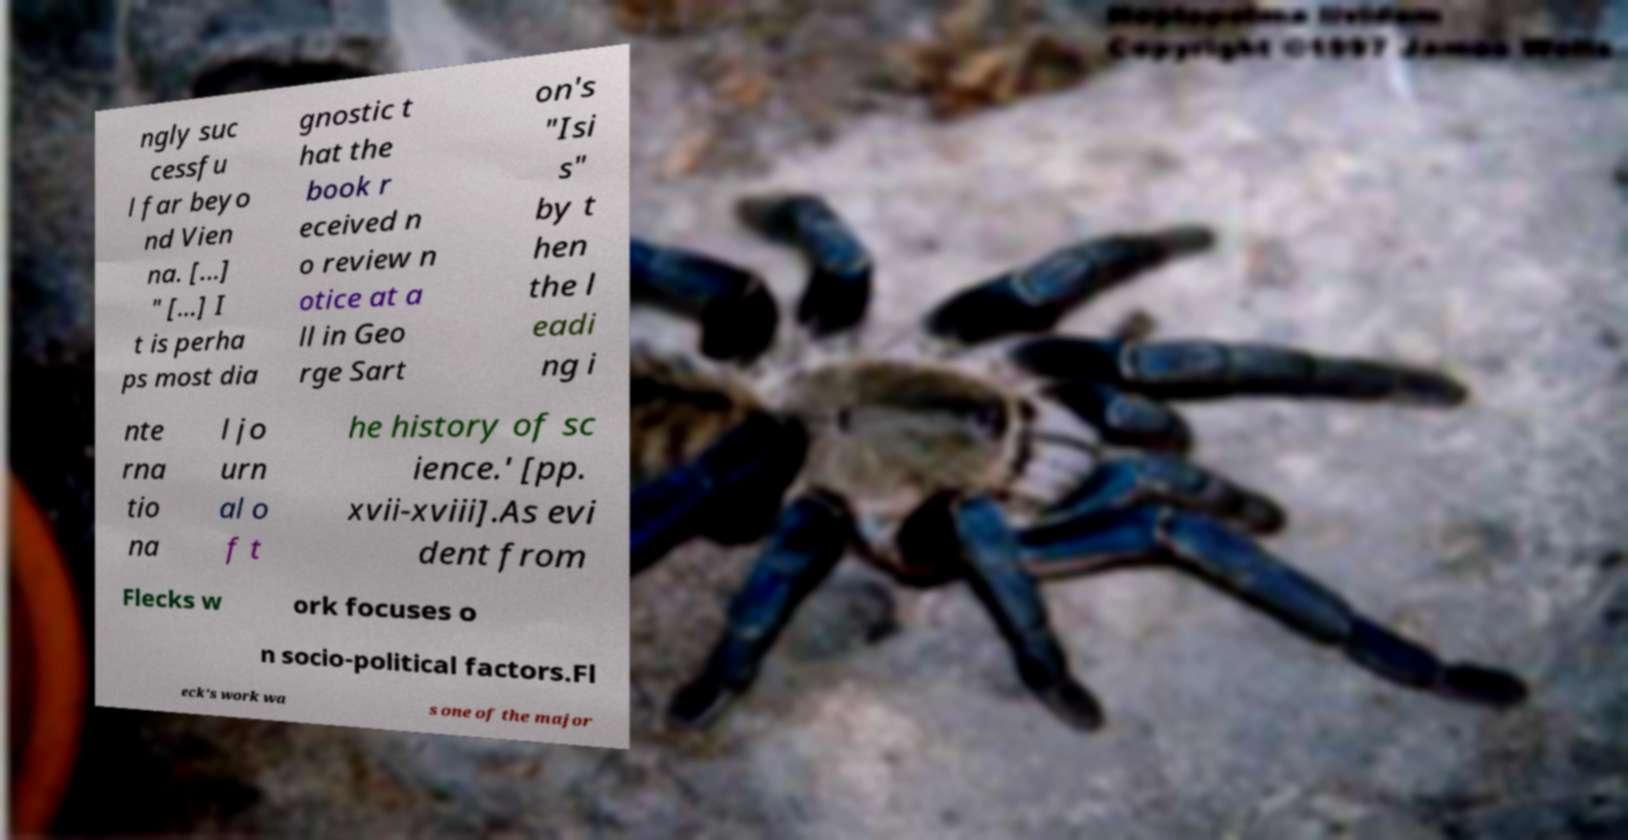For documentation purposes, I need the text within this image transcribed. Could you provide that? ngly suc cessfu l far beyo nd Vien na. [...] " [...] I t is perha ps most dia gnostic t hat the book r eceived n o review n otice at a ll in Geo rge Sart on's "Isi s" by t hen the l eadi ng i nte rna tio na l jo urn al o f t he history of sc ience.' [pp. xvii-xviii].As evi dent from Flecks w ork focuses o n socio-political factors.Fl eck's work wa s one of the major 